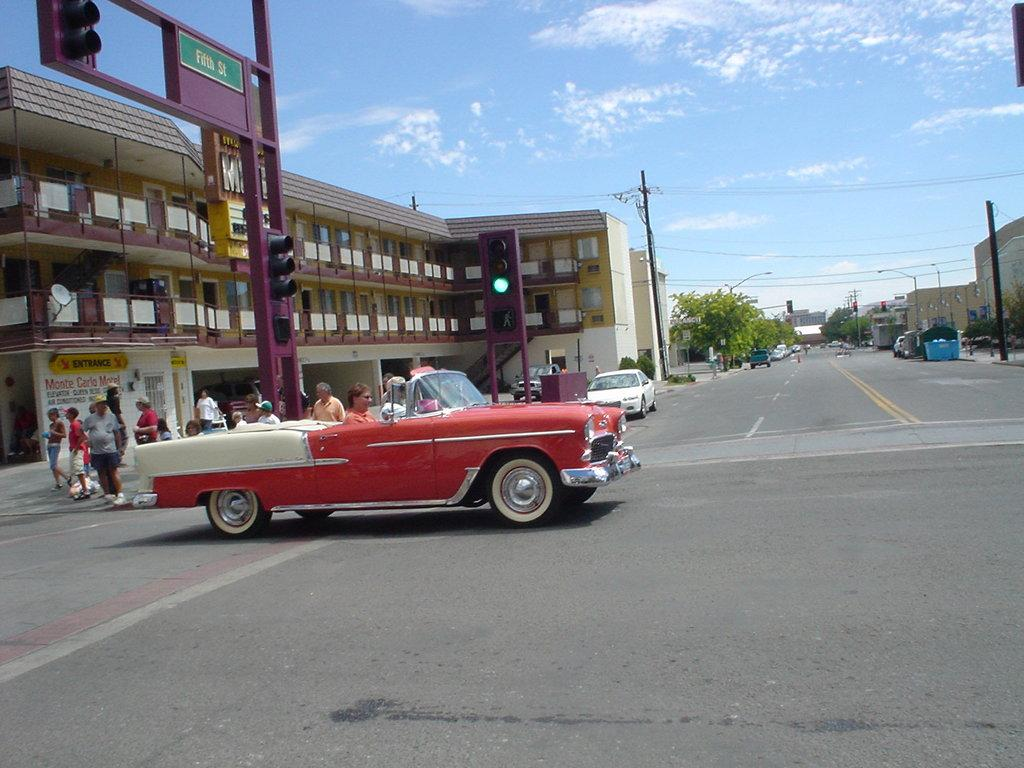What is the main subject of the image? The main subject of the image is a car moving. What else can be seen in the image besides the car? There are people walking on a walkway, buildings, trees, and a clear sky visible in the image. What are the people in the image doing? The people in the image are walking on a walkway. What type of environment is depicted in the image? The image shows an urban environment with buildings, trees, and a walkway. What type of breakfast is being served in the office in the image? There is no office or breakfast present in the image. What type of spy equipment can be seen in the image? There is no spy equipment present in the image. 